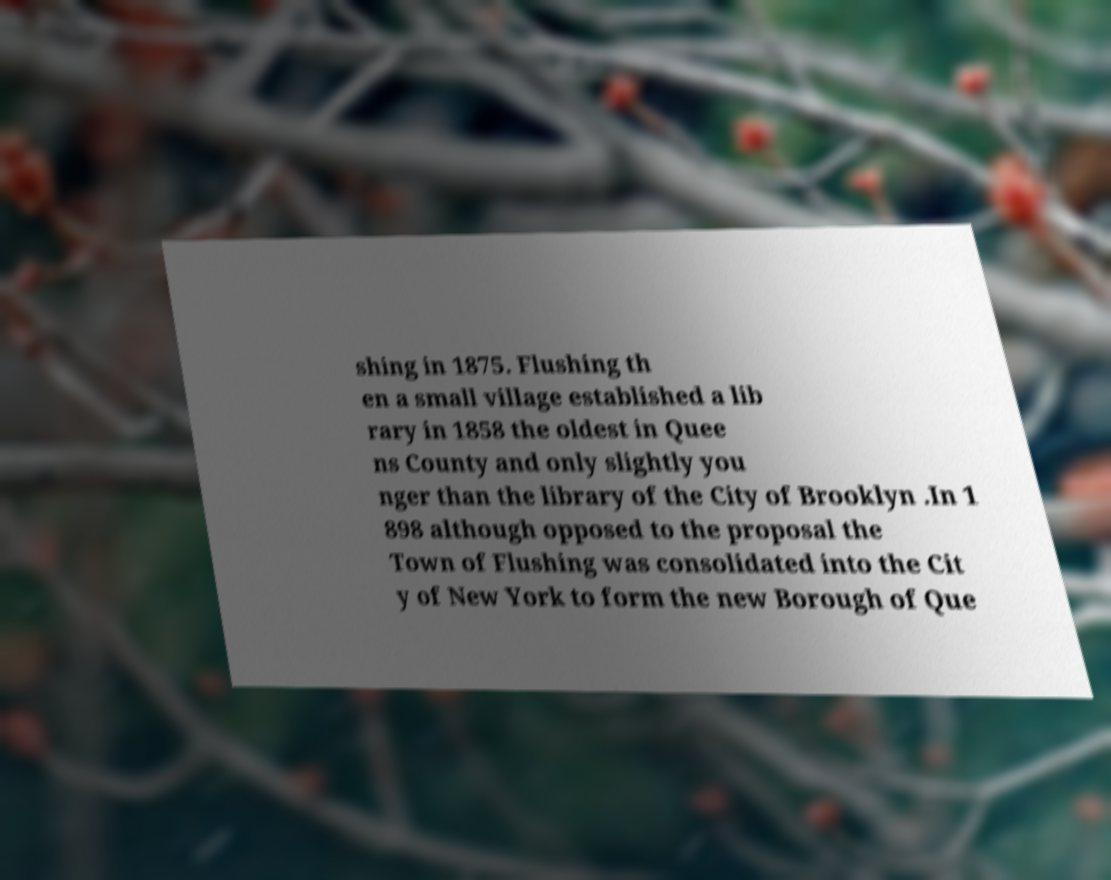Can you read and provide the text displayed in the image?This photo seems to have some interesting text. Can you extract and type it out for me? shing in 1875. Flushing th en a small village established a lib rary in 1858 the oldest in Quee ns County and only slightly you nger than the library of the City of Brooklyn .In 1 898 although opposed to the proposal the Town of Flushing was consolidated into the Cit y of New York to form the new Borough of Que 